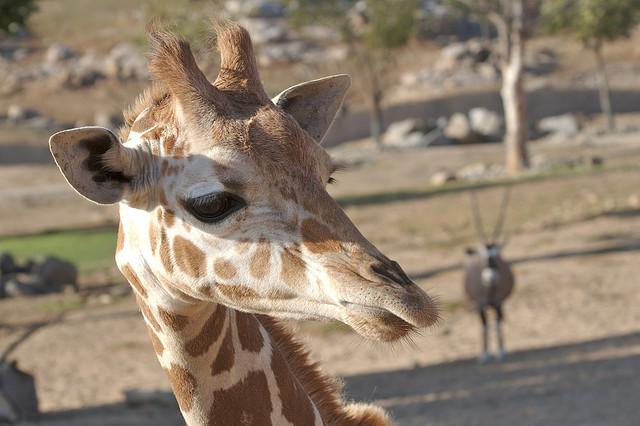Does the giraffe look happy?
Give a very brief answer. No. What are the things on the top of the giraffe's head?
Write a very short answer. Horns. What color is the giraffe?
Be succinct. Brown and white. How many horns does the animal in the background have?
Answer briefly. 2. Was the photographer standing on the ground for this shot?
Write a very short answer. No. 